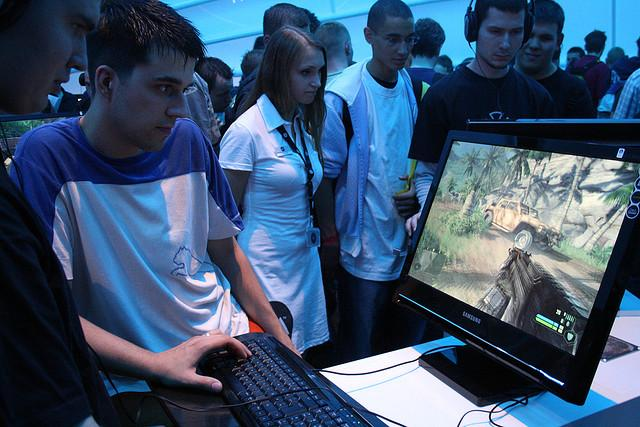What are the two men watching?

Choices:
A) news report
B) video game
C) movie
D) music video video game 